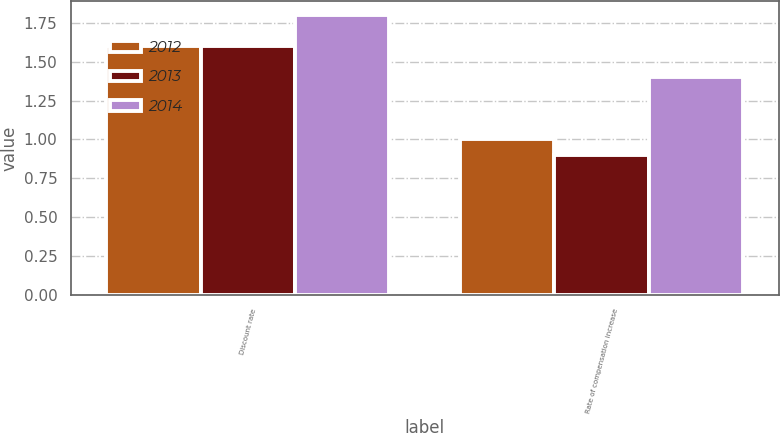<chart> <loc_0><loc_0><loc_500><loc_500><stacked_bar_chart><ecel><fcel>Discount rate<fcel>Rate of compensation increase<nl><fcel>2012<fcel>1.6<fcel>1<nl><fcel>2013<fcel>1.6<fcel>0.9<nl><fcel>2014<fcel>1.8<fcel>1.4<nl></chart> 